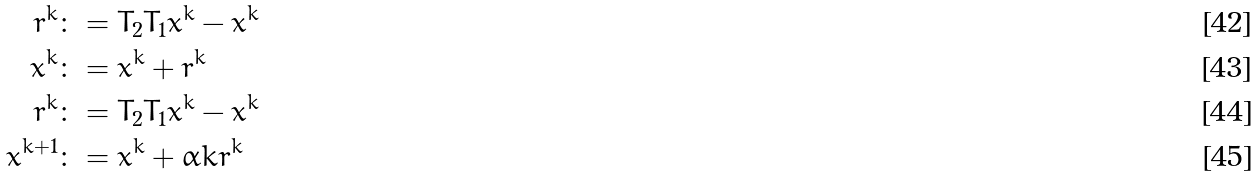<formula> <loc_0><loc_0><loc_500><loc_500>r ^ { k } & \colon = T _ { 2 } T _ { 1 } x ^ { k } - x ^ { k } \\ \bar { x } ^ { k } & \colon = x ^ { k } + r ^ { k } \\ \bar { r } ^ { k } & \colon = T _ { 2 } T _ { 1 } \bar { x } ^ { k } - \bar { x } ^ { k } \\ x ^ { k + 1 } & \colon = x ^ { k } + \alpha k r ^ { k }</formula> 